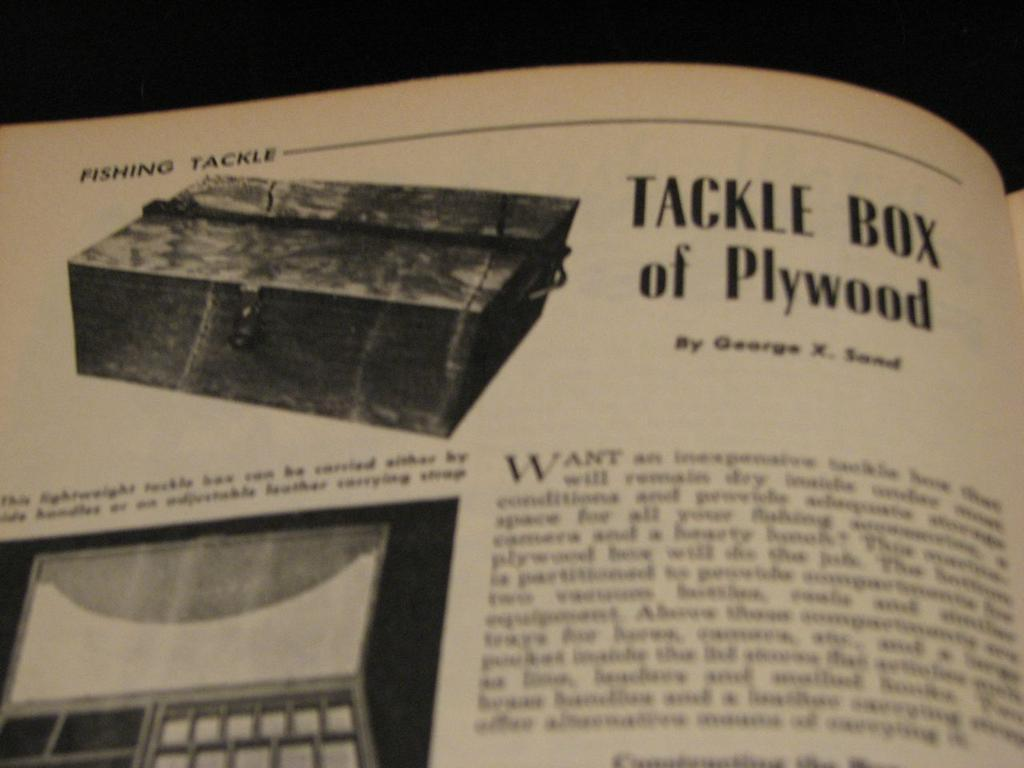<image>
Render a clear and concise summary of the photo. Book that includes a tackle box of plywood 